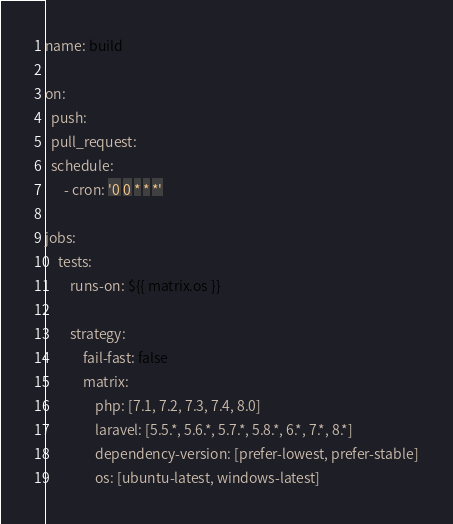<code> <loc_0><loc_0><loc_500><loc_500><_YAML_>name: build

on:
  push:
  pull_request:
  schedule:
      - cron: '0 0 * * *'

jobs:
    tests:
        runs-on: ${{ matrix.os }}

        strategy:
            fail-fast: false
            matrix:
                php: [7.1, 7.2, 7.3, 7.4, 8.0]
                laravel: [5.5.*, 5.6.*, 5.7.*, 5.8.*, 6.*, 7.*, 8.*]
                dependency-version: [prefer-lowest, prefer-stable]
                os: [ubuntu-latest, windows-latest]</code> 